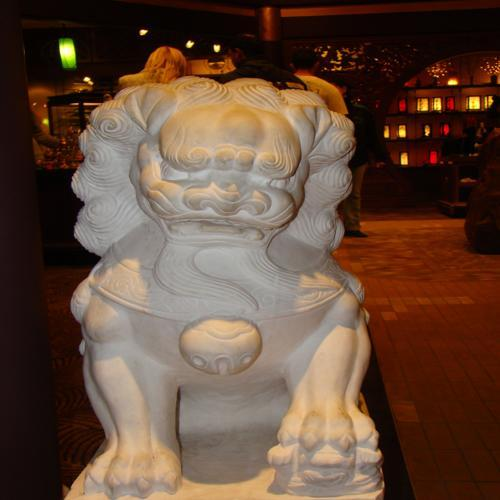What are some of the distinctive features of this statue? One of the key features of this guardian lion statue is its robust and stylized form, often conveying power and majesty. The mane is elaborately carved, adding to the statue's imposing appearance. Additionally, the expression on the lion's face is typically fierce, with a wide-open mouth which might symbolize the flowing of energy or the warding off of evil spirits. 